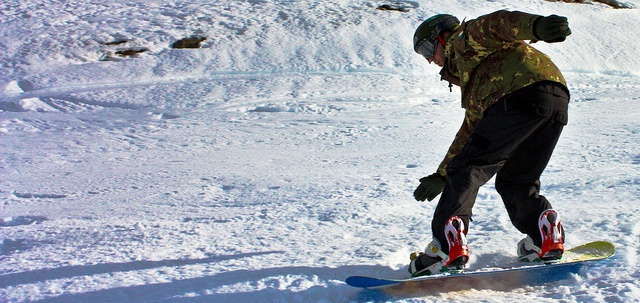Describe the objects in this image and their specific colors. I can see people in lavender, black, maroon, olive, and gray tones and snowboard in lavender, gray, navy, lightgray, and olive tones in this image. 